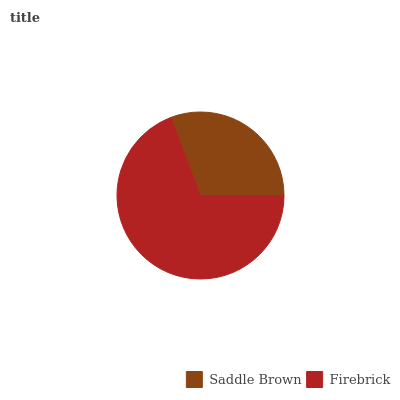Is Saddle Brown the minimum?
Answer yes or no. Yes. Is Firebrick the maximum?
Answer yes or no. Yes. Is Firebrick the minimum?
Answer yes or no. No. Is Firebrick greater than Saddle Brown?
Answer yes or no. Yes. Is Saddle Brown less than Firebrick?
Answer yes or no. Yes. Is Saddle Brown greater than Firebrick?
Answer yes or no. No. Is Firebrick less than Saddle Brown?
Answer yes or no. No. Is Firebrick the high median?
Answer yes or no. Yes. Is Saddle Brown the low median?
Answer yes or no. Yes. Is Saddle Brown the high median?
Answer yes or no. No. Is Firebrick the low median?
Answer yes or no. No. 